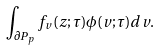<formula> <loc_0><loc_0><loc_500><loc_500>\int _ { \partial P _ { p } } f _ { v } ( z ; \tau ) \phi ( v ; \tau ) d v .</formula> 